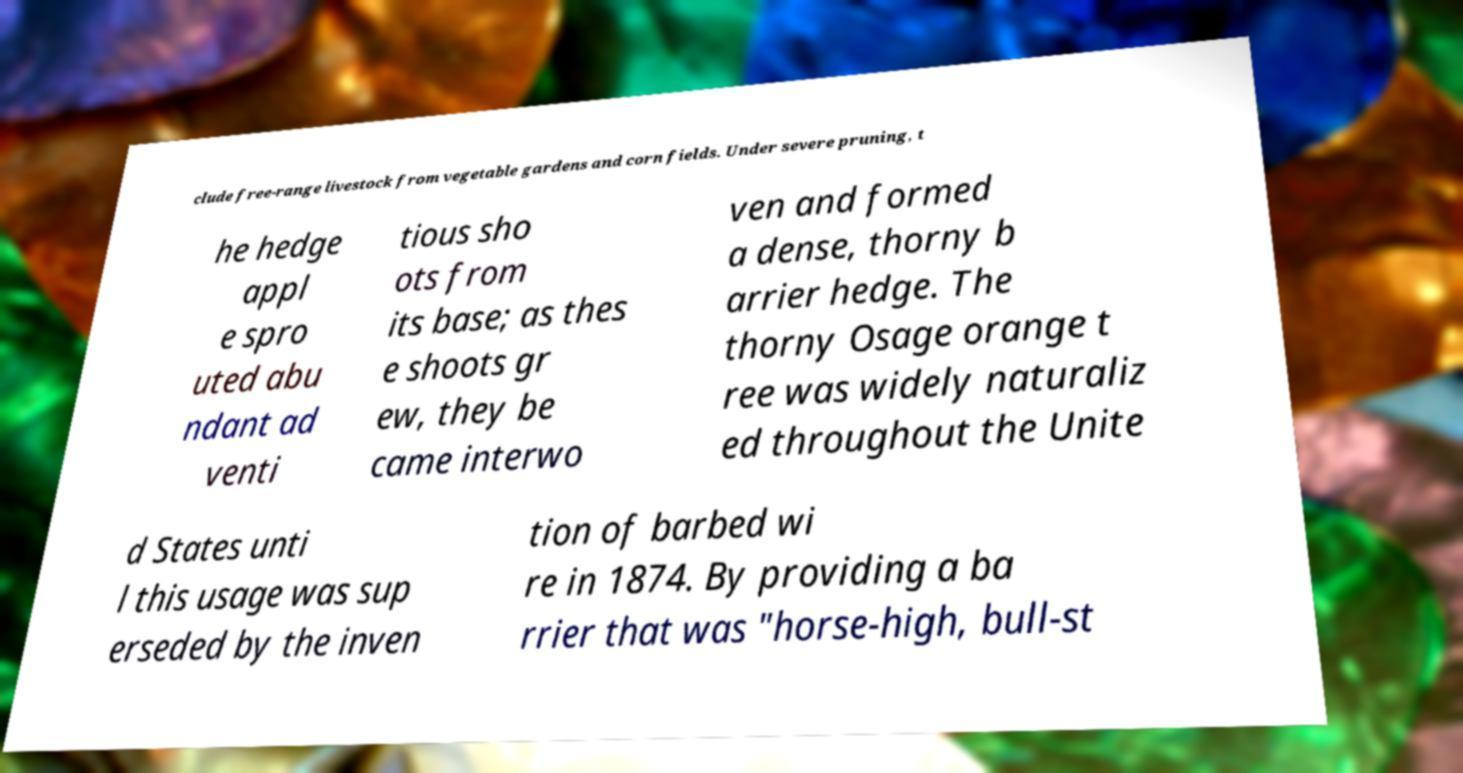I need the written content from this picture converted into text. Can you do that? clude free-range livestock from vegetable gardens and corn fields. Under severe pruning, t he hedge appl e spro uted abu ndant ad venti tious sho ots from its base; as thes e shoots gr ew, they be came interwo ven and formed a dense, thorny b arrier hedge. The thorny Osage orange t ree was widely naturaliz ed throughout the Unite d States unti l this usage was sup erseded by the inven tion of barbed wi re in 1874. By providing a ba rrier that was "horse-high, bull-st 